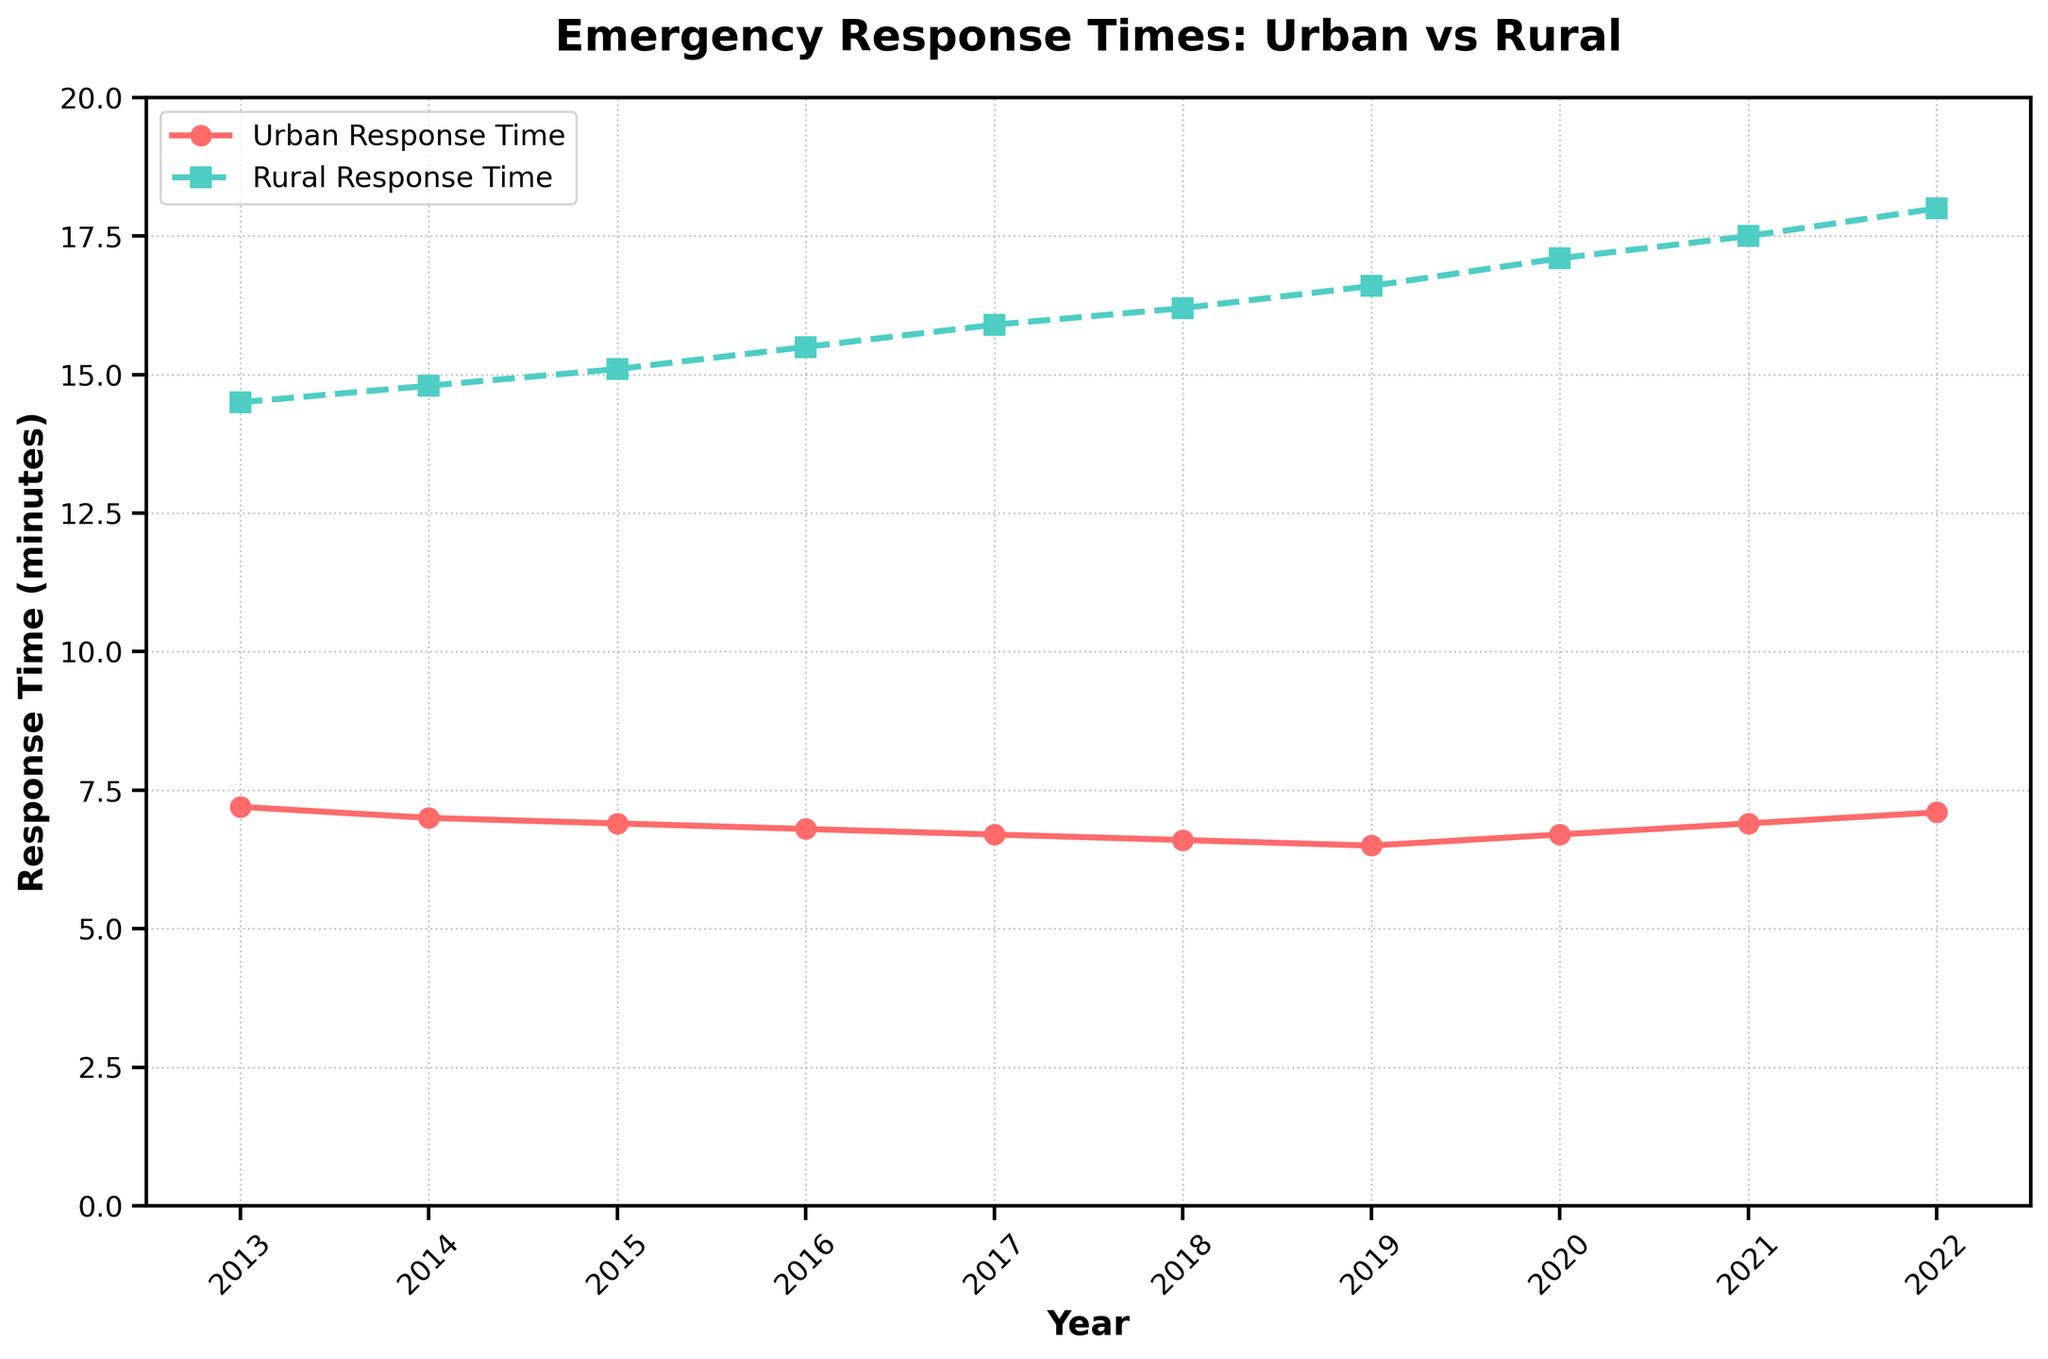What is the average urban response time across the decade? Add all urban response times and divide by the number of years. (7.2 + 7.0 + 6.9 + 6.8 + 6.7 + 6.6 + 6.5 + 6.7 + 6.9 + 7.1) / 10 ≈ 6.84 minutes
Answer: 6.84 minutes How much longer is the rural response time compared to the urban response time in 2022? Subtract the urban response time from the rural response time for 2022. 18.0 - 7.1 = 10.9 minutes
Answer: 10.9 minutes Has the urban response time increased or decreased over the decade? Compare the urban response time in 2013 with that in 2022. It started at 7.2 minutes in 2013 and is 7.1 minutes in 2022, slightly decreased overall.
Answer: Decreased In which year did the rural response time first exceed 17 minutes? Identify the first year where the rural response time is over 17 minutes in the chart. This occurs in 2020 with 17.1 minutes.
Answer: 2020 What is the difference between the highest and lowest urban response times? Identify the highest and lowest urban response times and then subtract the lowest value from the highest one. Highest is 7.2 minutes in 2013, lowest is 6.5 minutes in 2019, difference is 7.2 - 6.5 = 0.7 minutes.
Answer: 0.7 minutes Does any year show a decrease in both urban and rural response times from the previous year? Look for years where both values decrease when compared to the previous year. Both urban and rural times decreased from 2014 to 2015. Urban: 7.0 to 6.9 and Rural: 14.8 to 15.1.
Answer: 2015 During which year was the gap between rural and urban response times the widest? Identify the year with the largest difference between rural and urban times. In 2022, the gap is 18.0 - 7.1 = 10.9 minutes, which is the widest.
Answer: 2022 Which year shows the smallest gap between urban and rural response times? Identify the year with the smallest difference between urban and rural times. In 2013, the gap is 14.5 - 7.2 = 7.3 minutes, which is the smallest.
Answer: 2013 